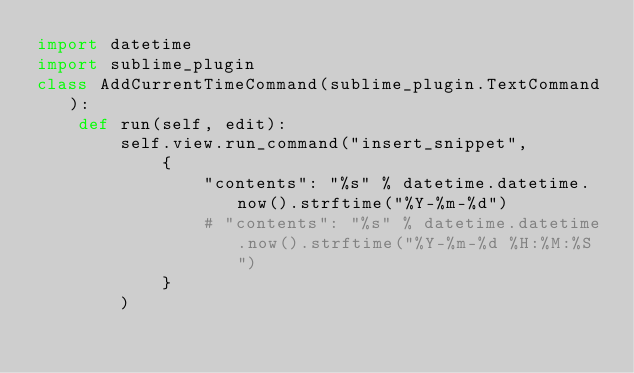<code> <loc_0><loc_0><loc_500><loc_500><_Python_>import datetime
import sublime_plugin
class AddCurrentTimeCommand(sublime_plugin.TextCommand):
    def run(self, edit):
        self.view.run_command("insert_snippet", 
            {
                "contents": "%s" % datetime.datetime.now().strftime("%Y-%m-%d") 
                # "contents": "%s" % datetime.datetime.now().strftime("%Y-%m-%d %H:%M:%S") 
            }
        )</code> 